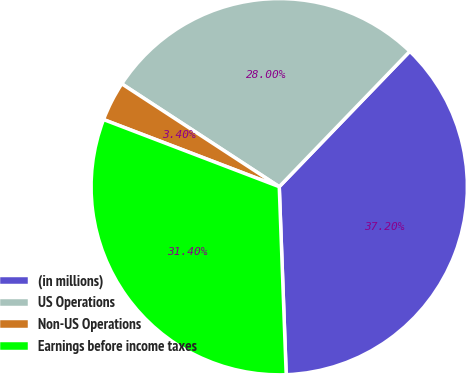Convert chart to OTSL. <chart><loc_0><loc_0><loc_500><loc_500><pie_chart><fcel>(in millions)<fcel>US Operations<fcel>Non-US Operations<fcel>Earnings before income taxes<nl><fcel>37.2%<fcel>28.0%<fcel>3.4%<fcel>31.4%<nl></chart> 